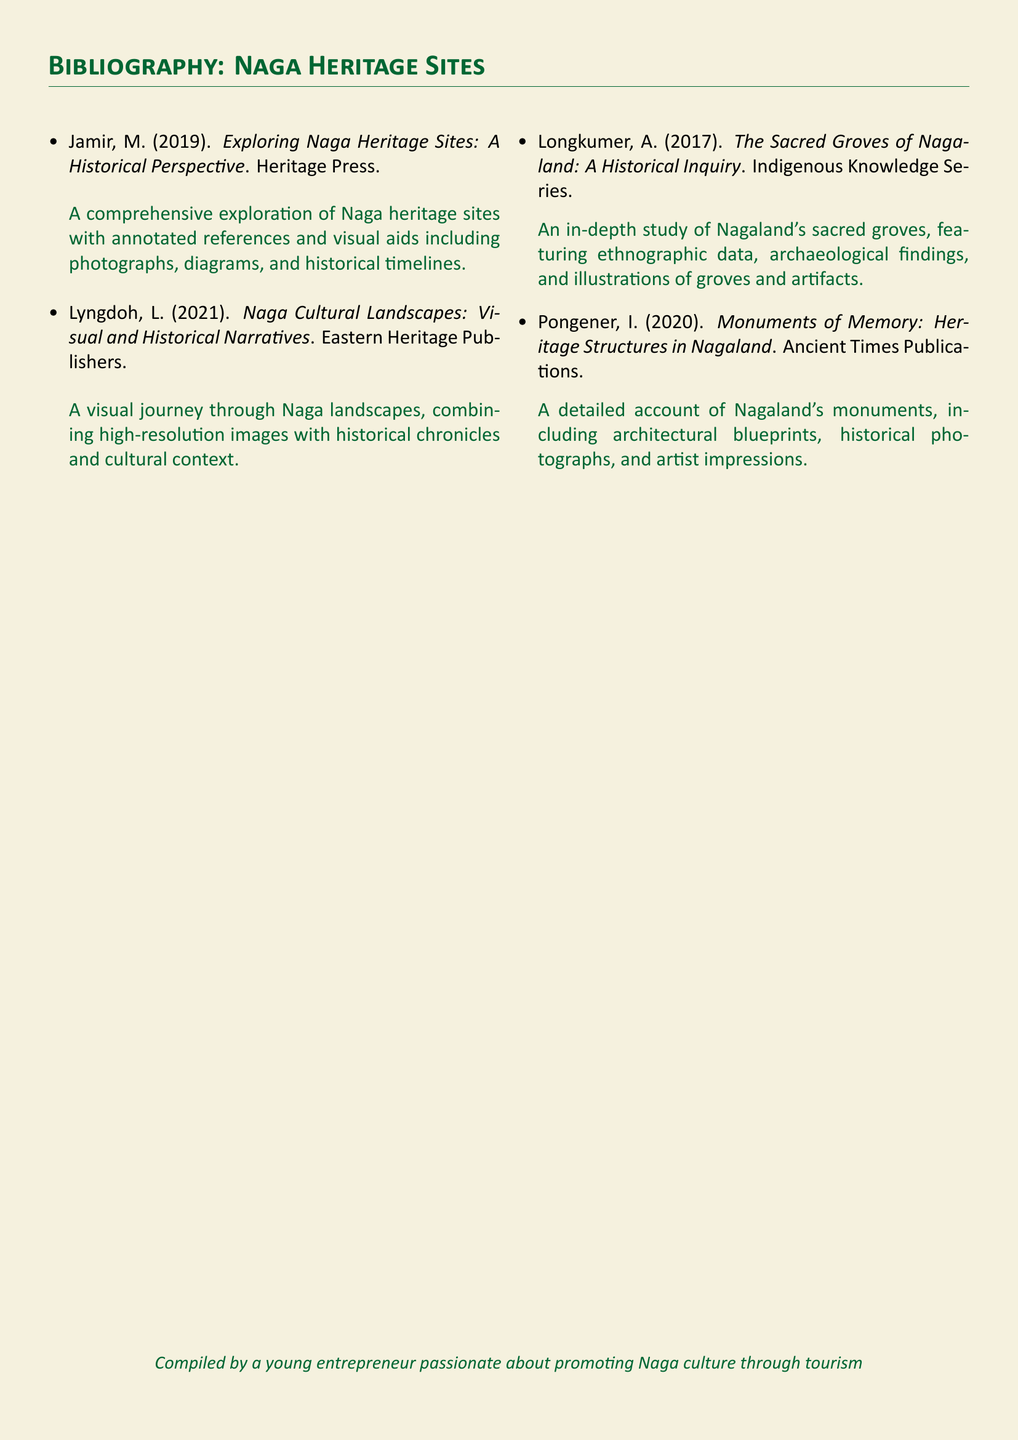What is the title of the first listed work? The first listed work is titled "Exploring Naga Heritage Sites: A Historical Perspective."
Answer: Exploring Naga Heritage Sites: A Historical Perspective Who is the author of the second work? The author of the second work is L. Lyngdoh.
Answer: L. Lyngdoh In what year was "The Sacred Groves of Nagaland: A Historical Inquiry" published? "The Sacred Groves of Nagaland: A Historical Inquiry" was published in 2017.
Answer: 2017 How many works are listed in the bibliography? The bibliography lists four works.
Answer: Four What type of visuals does the second work include? The second work includes high-resolution images.
Answer: High-resolution images What is the focus of "Monuments of Memory: Heritage Structures in Nagaland"? The focus is on heritage structures in Nagaland.
Answer: Heritage structures in Nagaland Who is the compiler of the bibliography? The compiler is described as a young entrepreneur.
Answer: A young entrepreneur What series is "The Sacred Groves of Nagaland" part of? It is part of the Indigenous Knowledge Series.
Answer: Indigenous Knowledge Series 